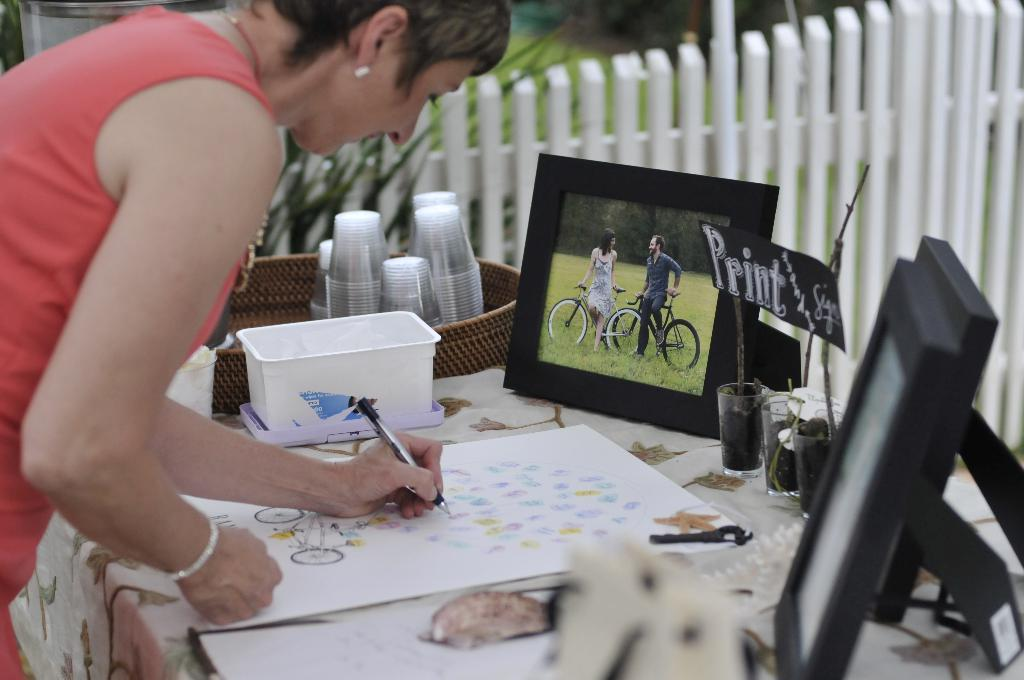What is the main subject of the image? There is a woman in the image. What is the woman doing in the image? The woman is standing and drawing on a paper. What is the woman holding in her hand? The woman is holding a pen in her hand. What other objects can be seen on the table in the image? There are glasses in a tub, a box, and photo frames on the table. How much money is being exchanged between the woman and the person in the photo frame? There is no indication of any money exchange in the image, nor is there a person in the photo frame. 